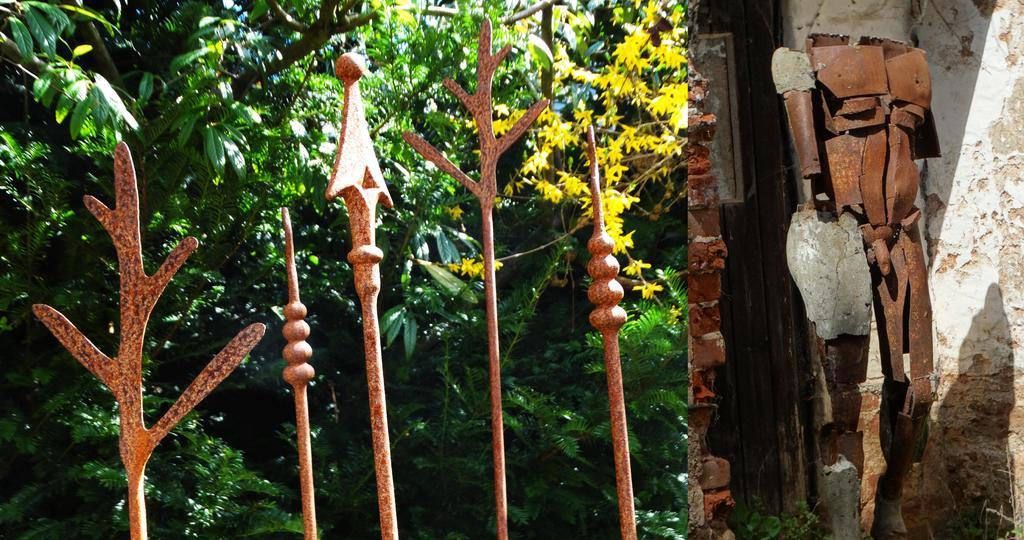What type of objects can be seen in the image? There are metal rods and a metal statue of a person in the image. What is the statue made of? The statue is made of metal. What can be seen in the background of the image? There are many trees and a wall in the background of the image. What type of polish does the statue use in the image? There is no mention of polish in the image, so it is not possible to answer this question. 